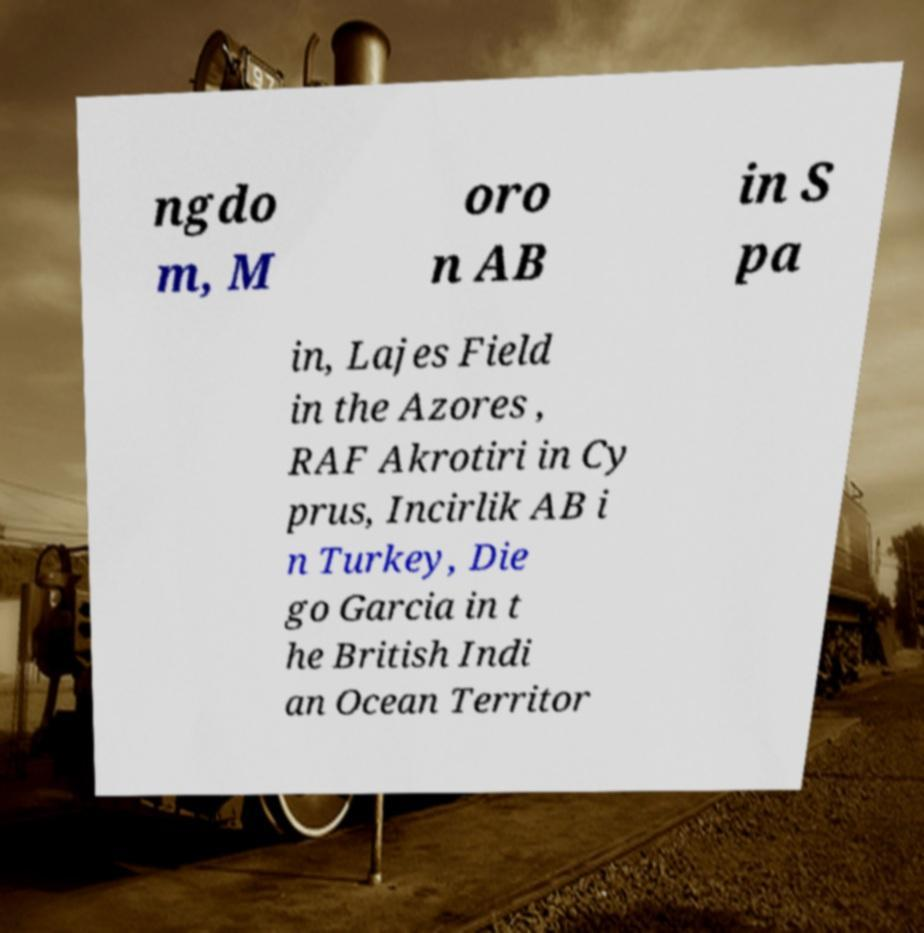Could you extract and type out the text from this image? ngdo m, M oro n AB in S pa in, Lajes Field in the Azores , RAF Akrotiri in Cy prus, Incirlik AB i n Turkey, Die go Garcia in t he British Indi an Ocean Territor 